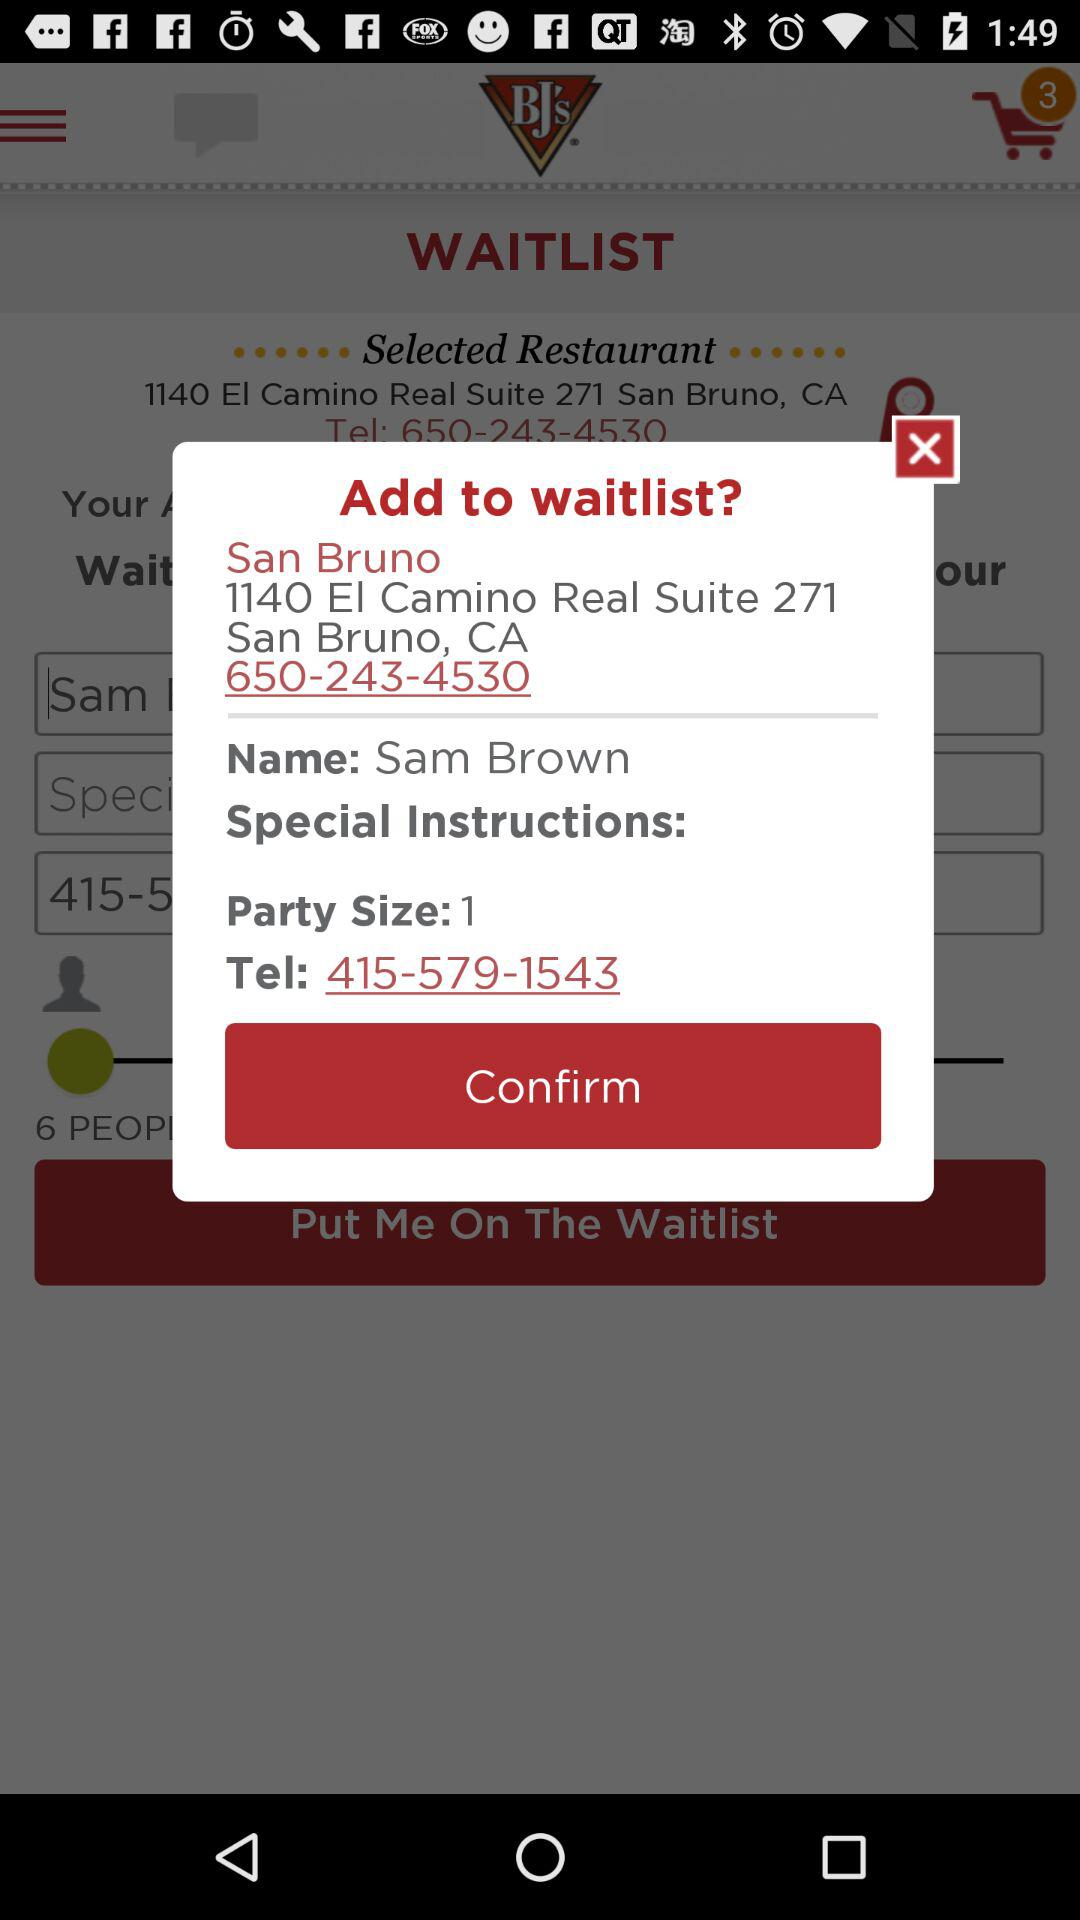What is the telephone number? The telephone number is 415-579-1543. 